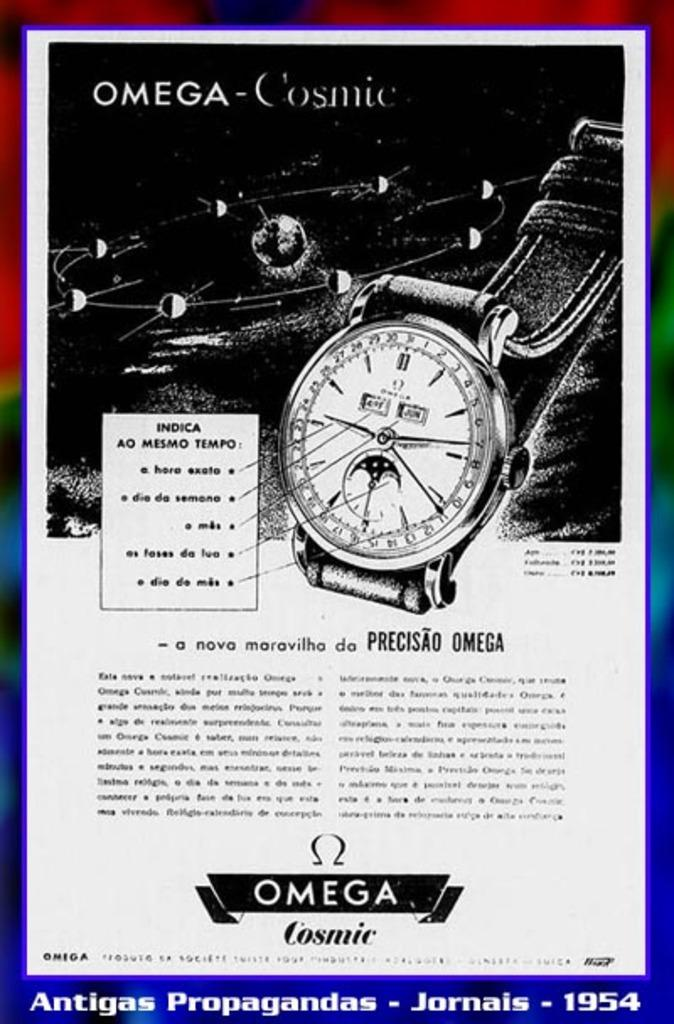<image>
Present a compact description of the photo's key features. Poster which shows a watch and the words "Omega Cosmic" on the bottom. 